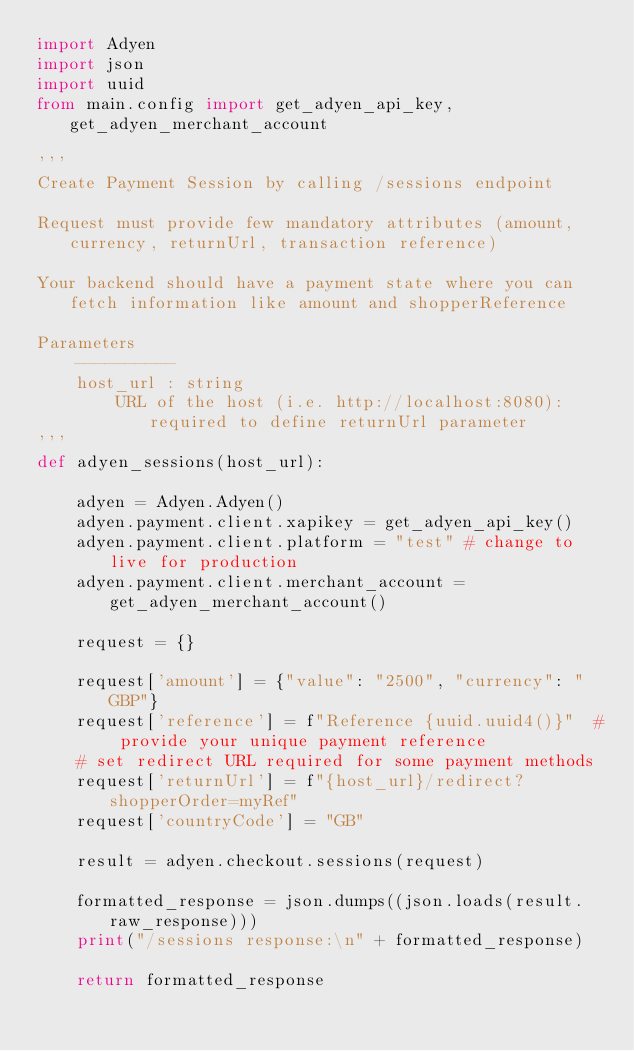<code> <loc_0><loc_0><loc_500><loc_500><_Python_>import Adyen
import json
import uuid
from main.config import get_adyen_api_key, get_adyen_merchant_account

'''
Create Payment Session by calling /sessions endpoint

Request must provide few mandatory attributes (amount, currency, returnUrl, transaction reference)

Your backend should have a payment state where you can fetch information like amount and shopperReference

Parameters
    ----------
    host_url : string
        URL of the host (i.e. http://localhost:8080): required to define returnUrl parameter
'''
def adyen_sessions(host_url):
    
    adyen = Adyen.Adyen()
    adyen.payment.client.xapikey = get_adyen_api_key()
    adyen.payment.client.platform = "test" # change to live for production
    adyen.payment.client.merchant_account = get_adyen_merchant_account()

    request = {}

    request['amount'] = {"value": "2500", "currency": "GBP"}
    request['reference'] = f"Reference {uuid.uuid4()}"  # provide your unique payment reference
    # set redirect URL required for some payment methods
    request['returnUrl'] = f"{host_url}/redirect?shopperOrder=myRef"
    request['countryCode'] = "GB"

    result = adyen.checkout.sessions(request)

    formatted_response = json.dumps((json.loads(result.raw_response)))
    print("/sessions response:\n" + formatted_response)

    return formatted_response
</code> 